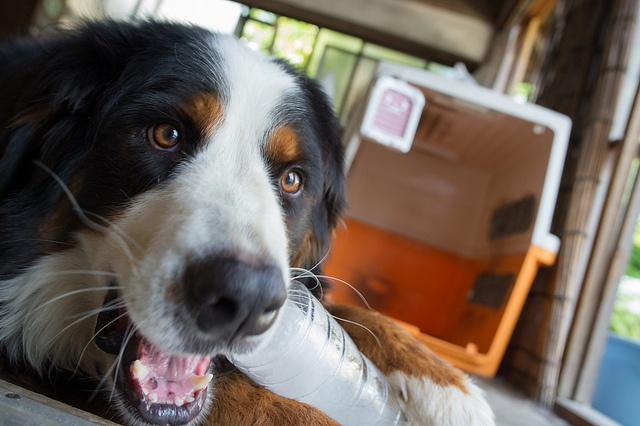Describe the objects in this image and their specific colors. I can see dog in black, gray, lightgray, and darkgray tones and bottle in black, lightgray, and darkgray tones in this image. 